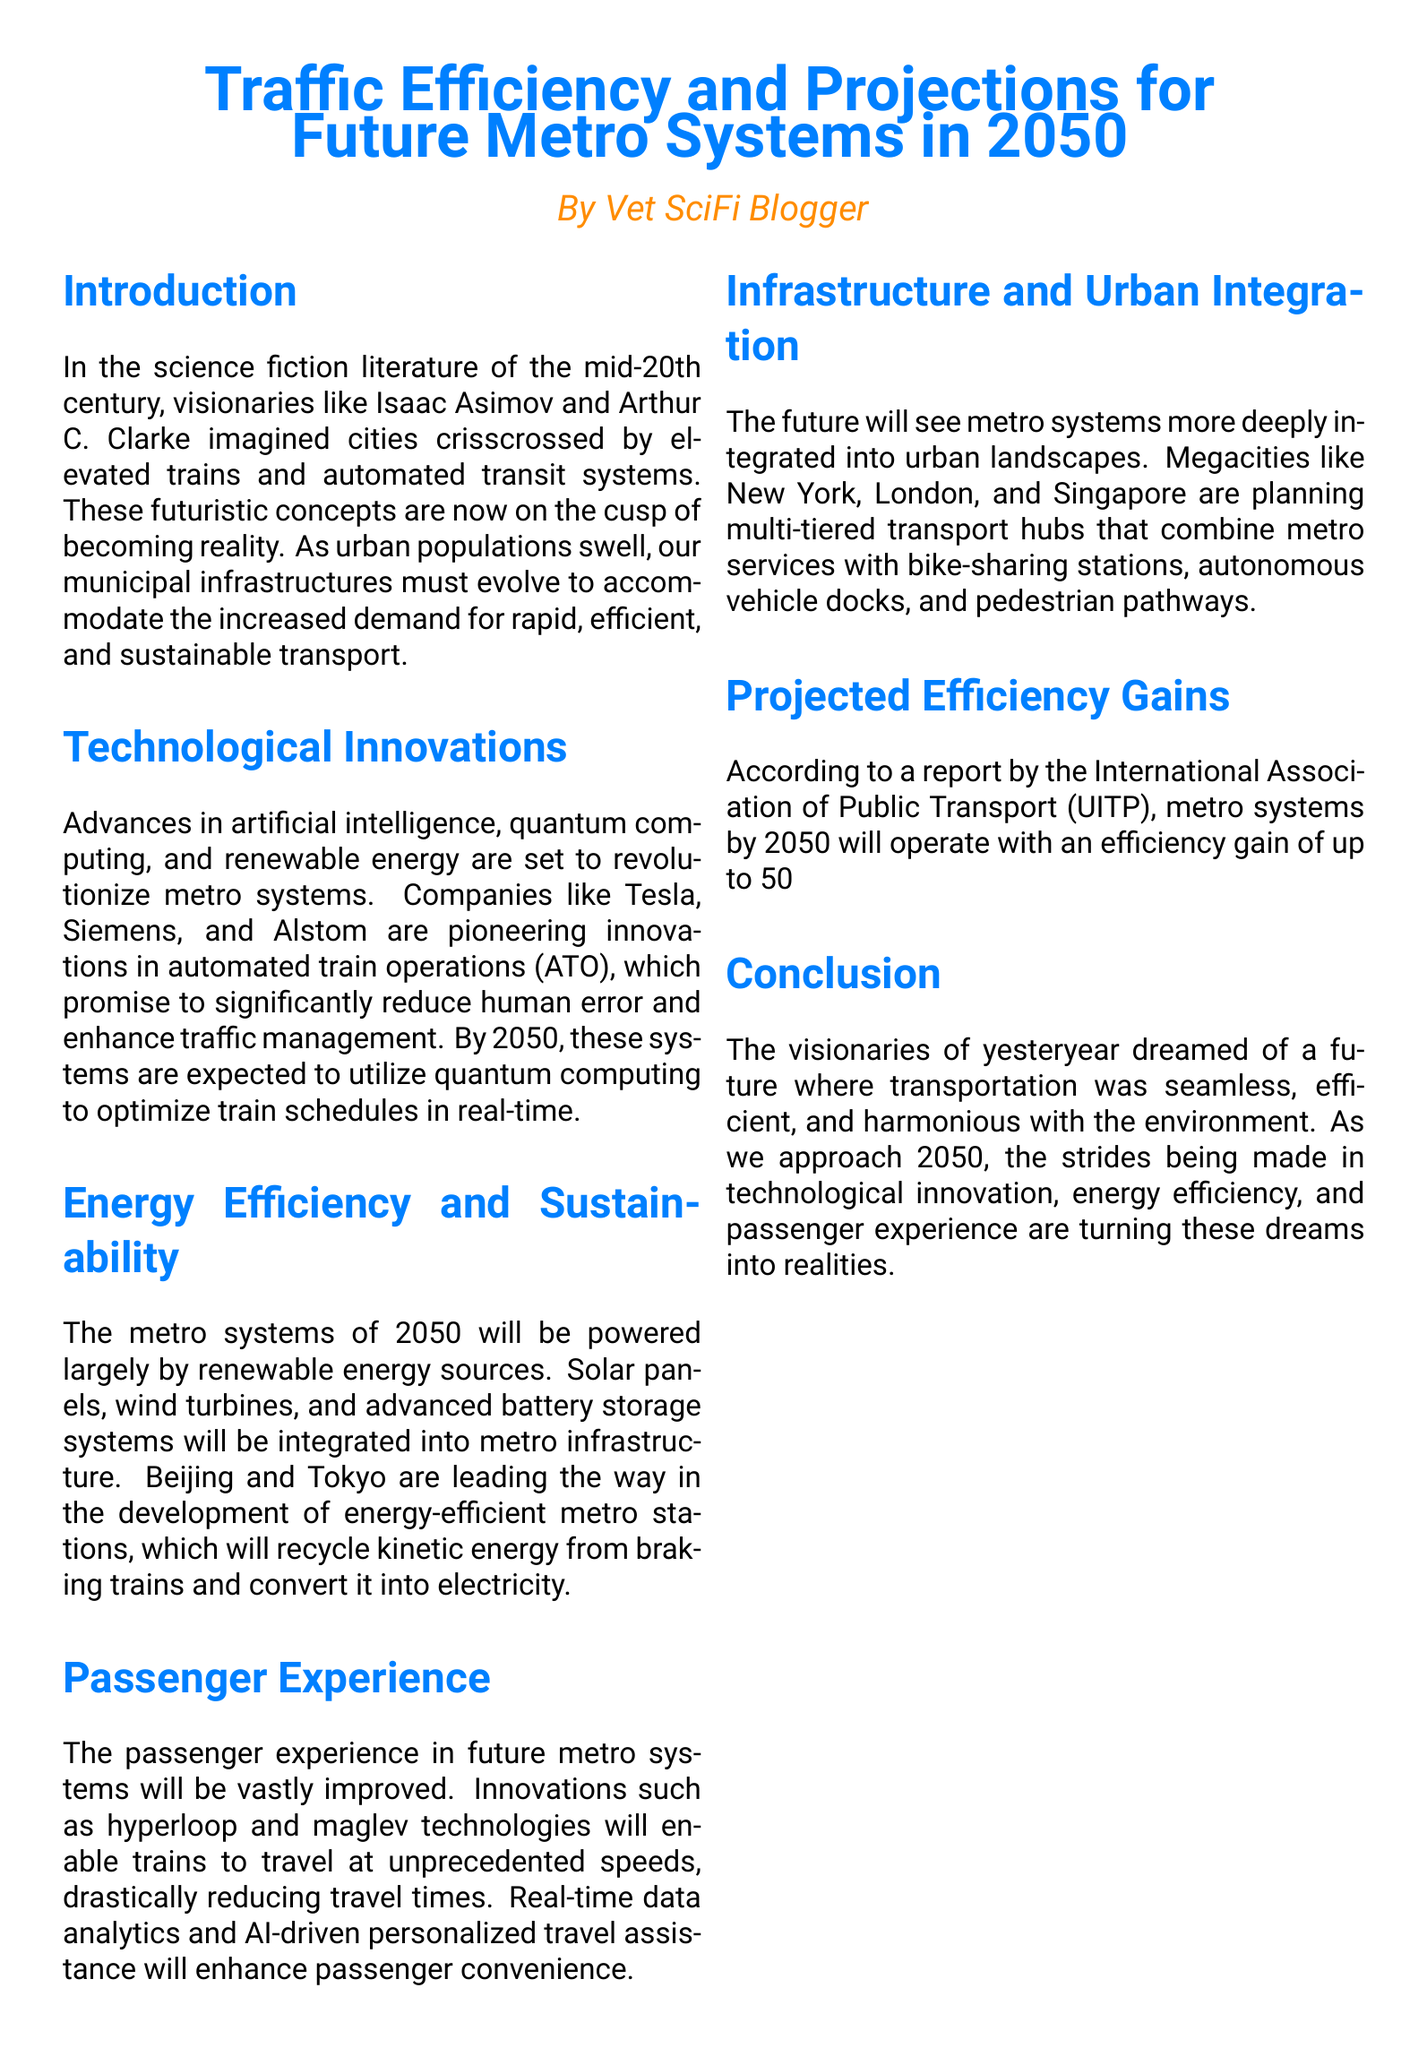What year are metro systems projected to be significantly more efficient? The document mentions projections for metro systems by the year 2050, emphasizing efficiency gains.
Answer: 2050 Which companies are mentioned as pioneers in innovations for metro systems? The companies highlighted for their contributions to metro innovations are Tesla, Siemens, and Alstom.
Answer: Tesla, Siemens, and Alstom What percentage of efficiency gain is expected by 2050 compared to 2020 levels? The document states that metro systems by 2050 will operate with an efficiency gain of up to 50% compared to 2020.
Answer: 50% What technologies will contribute to the improvement of passenger experiences? Innovations such as hyperloop and maglev technologies are expected to enhance passenger experiences in future metro systems.
Answer: hyperloop and maglev Which two cities are leading in the development of energy-efficient metro stations? Beijing and Tokyo are recognized in the document for their advancements in energy-efficient metro stations.
Answer: Beijing and Tokyo What type of energy sources will power metro systems in 2050? Metro systems in 2050 will be powered largely by renewable energy sources, as outlined in the document.
Answer: renewable energy What is one of the main features of the multi-tiered transport hubs being planned? The multi-tiered transport hubs are designed to integrate various transport services, including bike-sharing stations and autonomous vehicle docks.
Answer: multi-tiered transport hubs What is the vision of the early science fiction writers regarding transportation? Early science fiction writers envisioned a future where transportation was seamless, efficient, and harmonious with the environment.
Answer: seamless transportation 